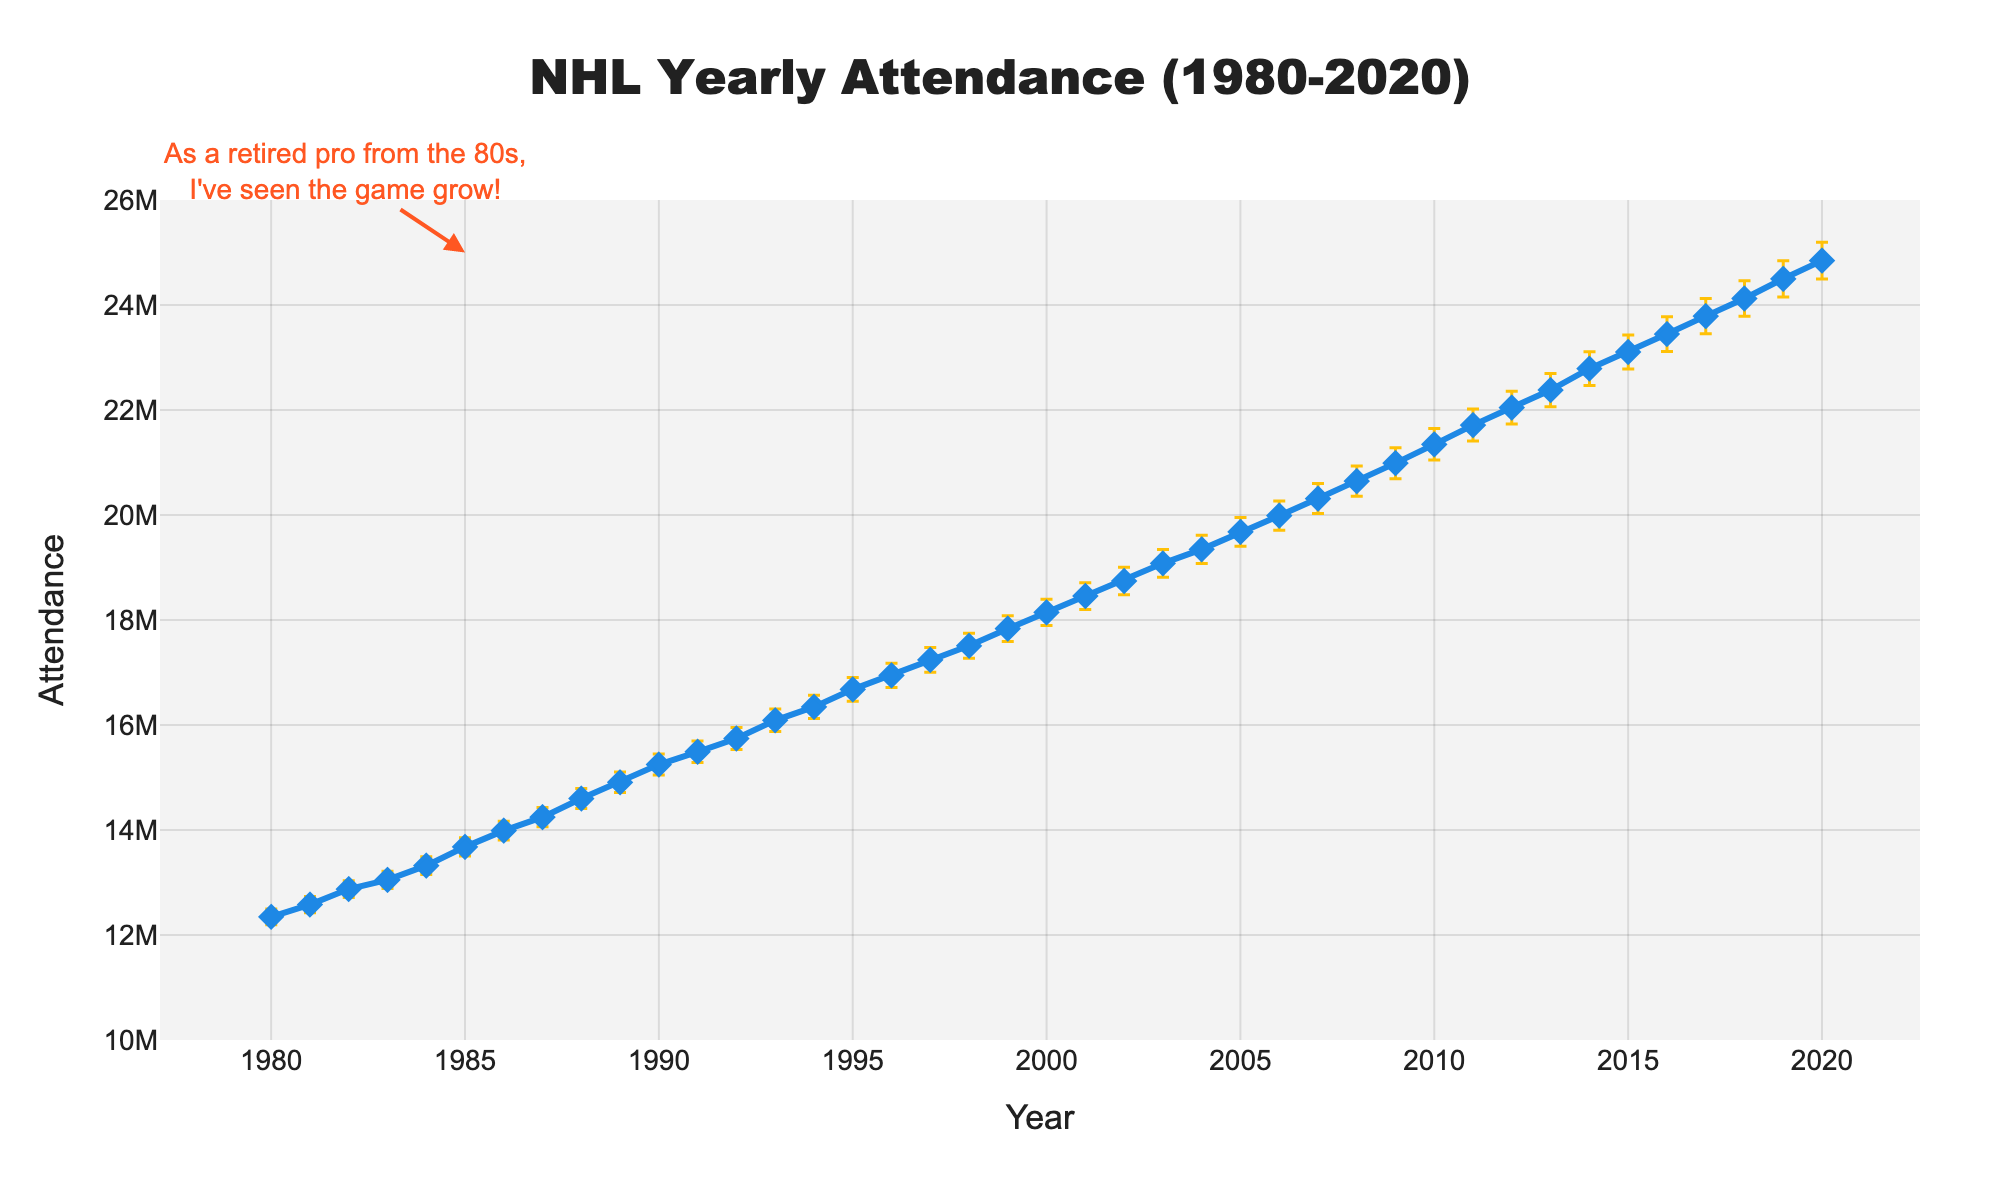What is the title of the figure? The title is displayed at the top center of the graph, indicating what the figure is about.
Answer: NHL Yearly Attendance (1980-2020) What is the y-axis title on the figure? The y-axis title is shown on the left side of the graph, indicating what is being measured on the vertical axis.
Answer: Attendance What is the average attendance for the first five years (1980-1984)? Add the attendance values for the years 1980 to 1984 and divide by 5 to get the average: (12345678 + 12578945 + 12874560 + 13050432 + 13321045) / 5.
Answer: 12874132 How much did the attendance increase from 1980 to 2020? Subtract the attendance in 1980 from the attendance in 2020: 24845678 - 12345678 = 12500000.
Answer: 12500000 In which year did the attendance first exceed 15 million? Look for the first year in which the y-value of the attendance curve is above 15 million. According to the graph, it happens in 1989.
Answer: 1989 Which year had the highest attendance shown in the graph? Identify the peak value on the attendance line. It occurs in the year 2020.
Answer: 2020 What is the margin of error for the attendance in 1990? Locate the year 1990 on the x-axis and refer to the error bar extending from this data point vertically. The margin of error for 1990 is 200,000.
Answer: 200000 How consistent is the growth trend in attendance over the years? Observe the line plot to see if the line generally increases, decreases, or remains steady. The line shows a consistent increasing trend from 1980 to 2020.
Answer: ConsistentIncreasing Which year saw the largest increase in attendance compared to the previous year, and what was the amount? Calculate the difference in attendance for each consecutive year and identify the maximum difference. For example, from 1985 to 1986 the difference is 13987654 - 13678910 = 308744 
The largest difference is from 1989 to 1990: 15245632 - 14907890 = 337742
Answer: 1990, 337742 